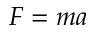<formula> <loc_0><loc_0><loc_500><loc_500>F = m a</formula> 